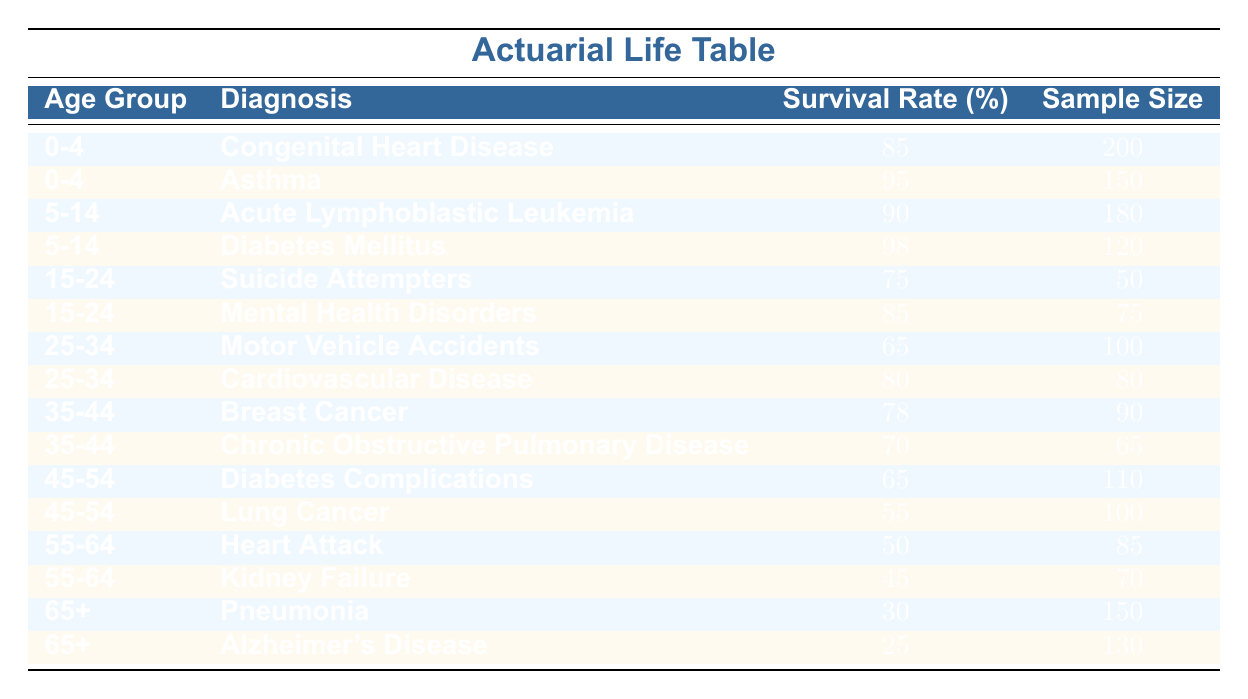What is the survival rate for patients aged 0-4 with Asthma? The table shows the survival rate for the age group 0-4 under the diagnosis of Asthma as 95%.
Answer: 95 Which diagnosis has the highest survival rate for patients aged 5-14? In the age group of 5-14, Diabetes Mellitus has a survival rate of 98%, which is higher than Acute Lymphoblastic Leukemia's 90%.
Answer: Diabetes Mellitus What is the average survival rate for patients aged 25-34? The survival rates for this age group are 65% for Motor Vehicle Accidents and 80% for Cardiovascular Disease. To find the average: (65 + 80) / 2 = 72.5.
Answer: 72.5 Is the survival rate for Alzheimer's Disease greater than that for Pneumonia? The survival rate for Pneumonia is 30%, while for Alzheimer's Disease, it is 25%. Therefore, Pneumonia's survival rate is greater.
Answer: Yes How many patients were included in the sample for Lung Cancer in the age group 45-54? The table indicates that the sample size for Lung Cancer is 100 patients within the age group 45-54.
Answer: 100 What is the difference in survival rates between patients aged 15-24 with Mental Health Disorders and those aged 55-64 with Kidney Failure? Mental Health Disorders in the 15-24 age group have a survival rate of 85%, while Kidney Failure in the 55-64 age group has a survival rate of 45%. The difference: 85 - 45 = 40.
Answer: 40 Which age group has the lowest survival rate for any diagnosis listed? Among all age groups, the 65+ group has the lowest survival rate at 25% for Alzheimer's Disease.
Answer: 25 How many patients in total were sampled for the age group 35-44? The sample sizes for the 35-44 age group are 90 for Breast Cancer and 65 for Chronic Obstructive Pulmonary Disease. Totaling them gives 90 + 65 = 155.
Answer: 155 Which age group shows the highest sample size? The age group 0-4 has the highest sample size with 200 patients for Congenital Heart Disease.
Answer: 200 